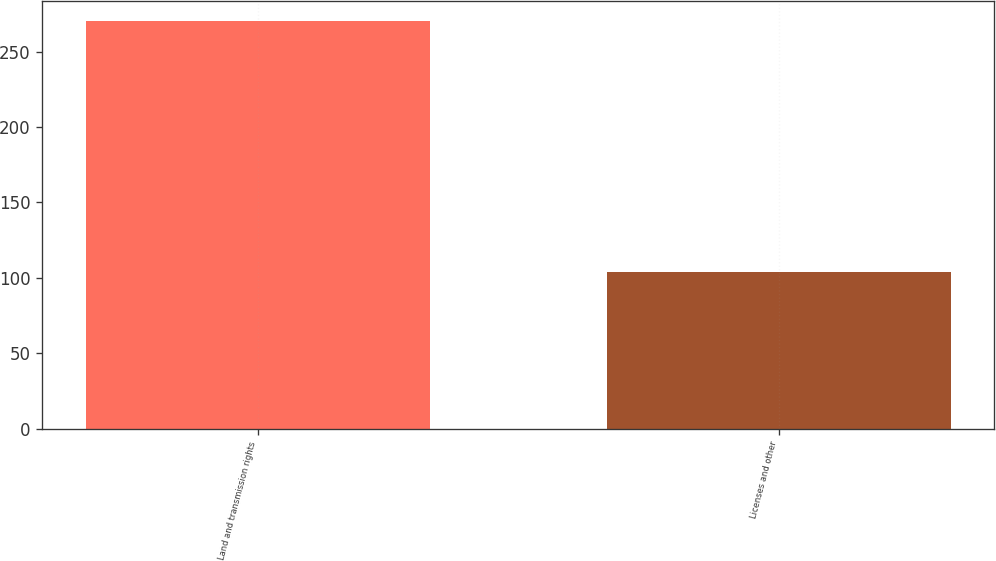Convert chart. <chart><loc_0><loc_0><loc_500><loc_500><bar_chart><fcel>Land and transmission rights<fcel>Licenses and other<nl><fcel>270<fcel>104<nl></chart> 